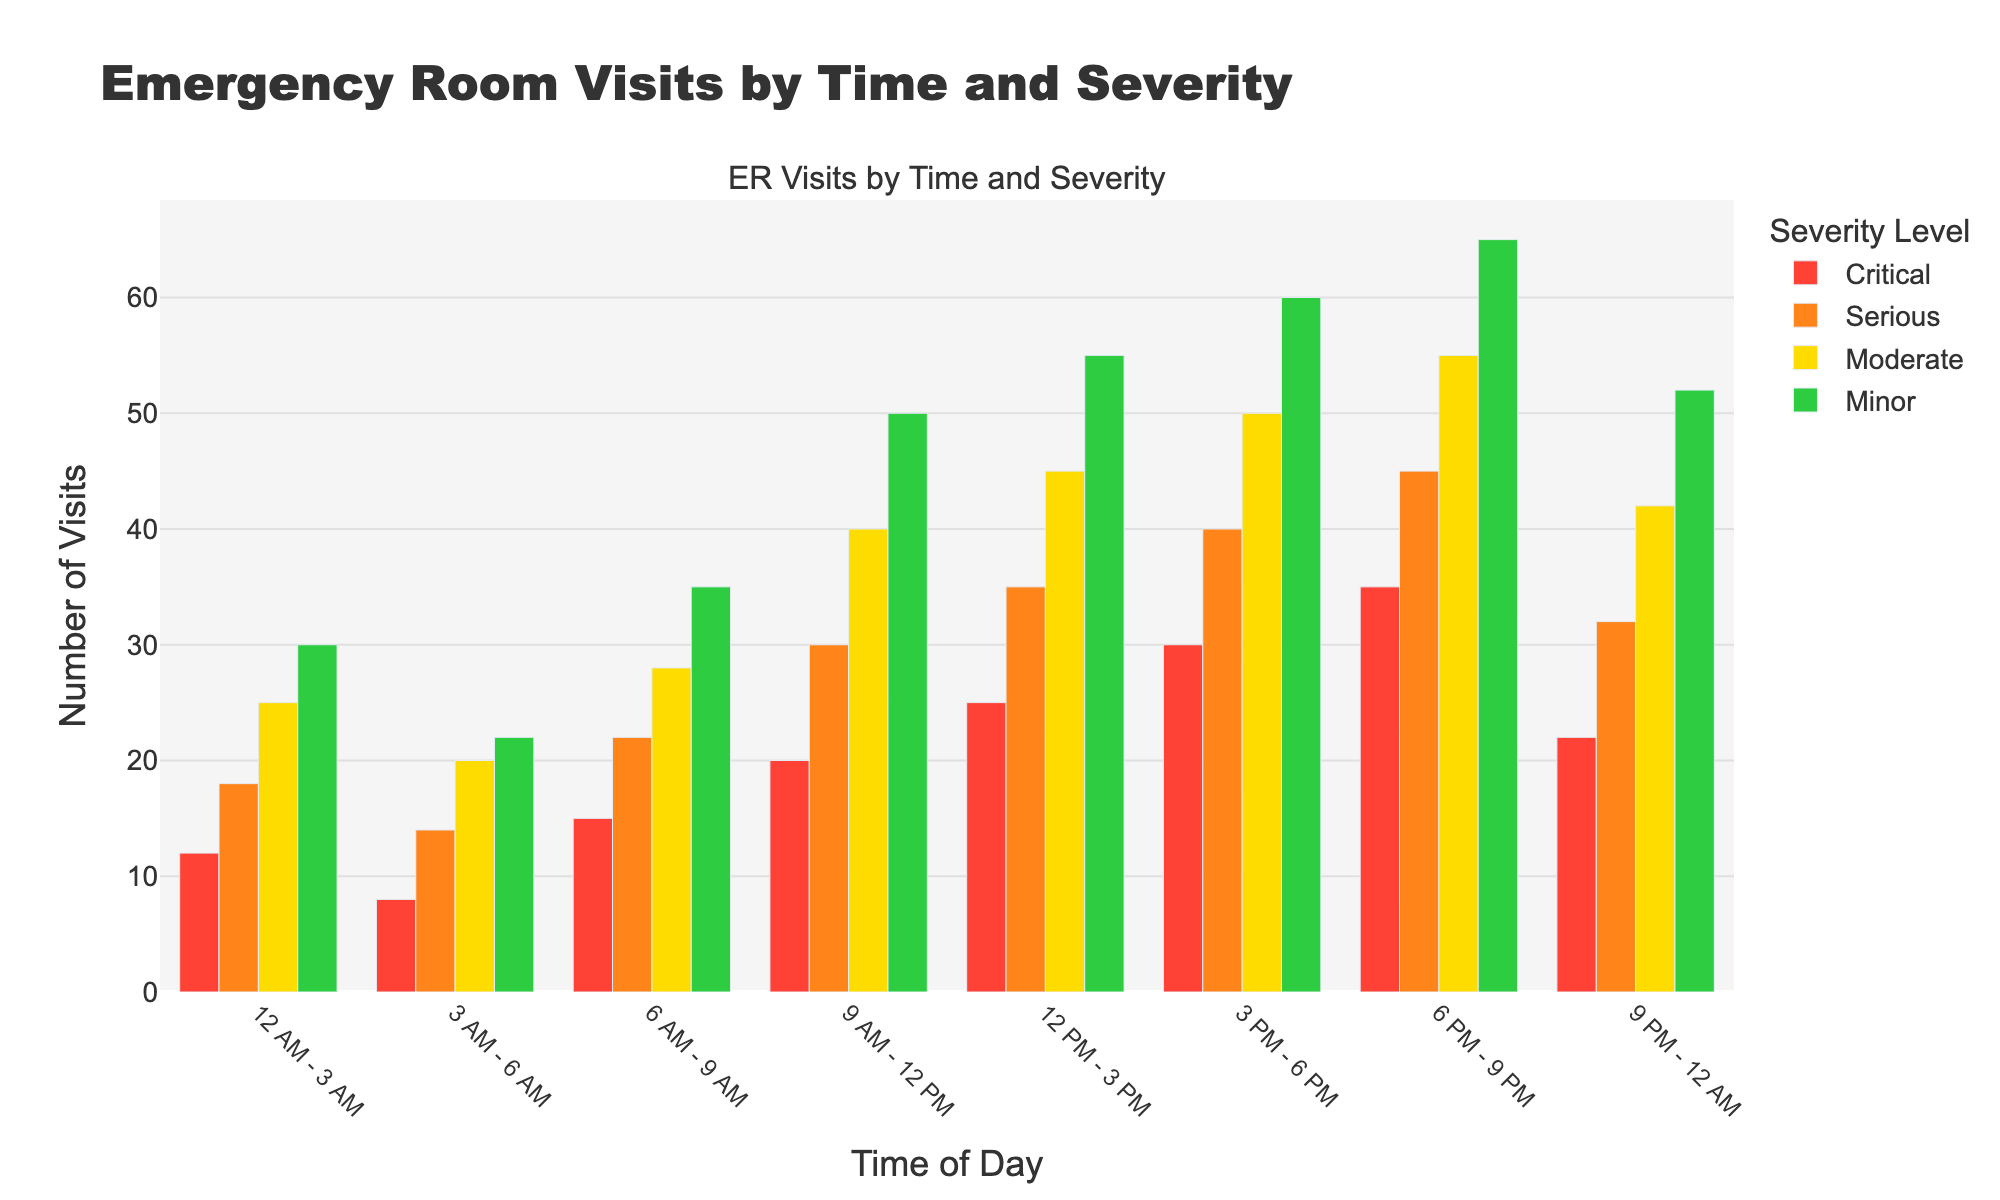What time slot has the highest number of critical visits? Identify the bars representing critical visits in all time slots and find the one with the tallest height. The highest critical visits occur between 6 PM - 9 PM with 35 visits.
Answer: 6 PM - 9 PM Which severity level sees the most consistent number of visits throughout the day? Compare the bar heights for each severity level across all time slots. "Serious" visits have relatively consistent heights, showing less variation compared to other severity levels.
Answer: Serious How many total visits occur between 12 PM and 3 PM? Sum up the values for all severity levels in the 12 PM - 3 PM period: Critical (25) + Serious (35) + Moderate (45) + Minor (55) = 160.
Answer: 160 What is the difference in the number of critical and minor visits between 12 AM - 3 AM? Subtract the number of critical visits from minor visits in 12 AM - 3 AM: Minor (30) - Critical (12) = 18.
Answer: 18 During which time slot do moderate visits peak? Identify the time slot with the tallest bar for moderate visits. The highest number of moderate visits occurs between 6 PM - 9 PM with 55 visits.
Answer: 6 PM - 9 PM Compare the number of serious visits at 9 AM - 12 PM and 3 PM - 6 PM. Which time slot has more serious visits? Compare the heights of the serious visit bars: 30 visits from 9 AM - 12 PM vs. 40 visits from 3 PM - 6 PM. The latter time slot has more serious visits.
Answer: 3 PM - 6 PM What is the total number of visits from 9 PM - 12 AM across all severity levels? Sum the visits for all severity levels in the 9 PM - 12 AM period: Critical (22) + Serious (32) + Moderate (42) + Minor (52) = 148.
Answer: 148 Which time slot has the fewest visits for any severity level, and what is that severity level? Scan all bars to find the shortest one across all time slots and severity levels. The fewest visits are critical visits from 3 AM - 6 AM at 8 visits.
Answer: Critical, 3 AM - 6 AM 